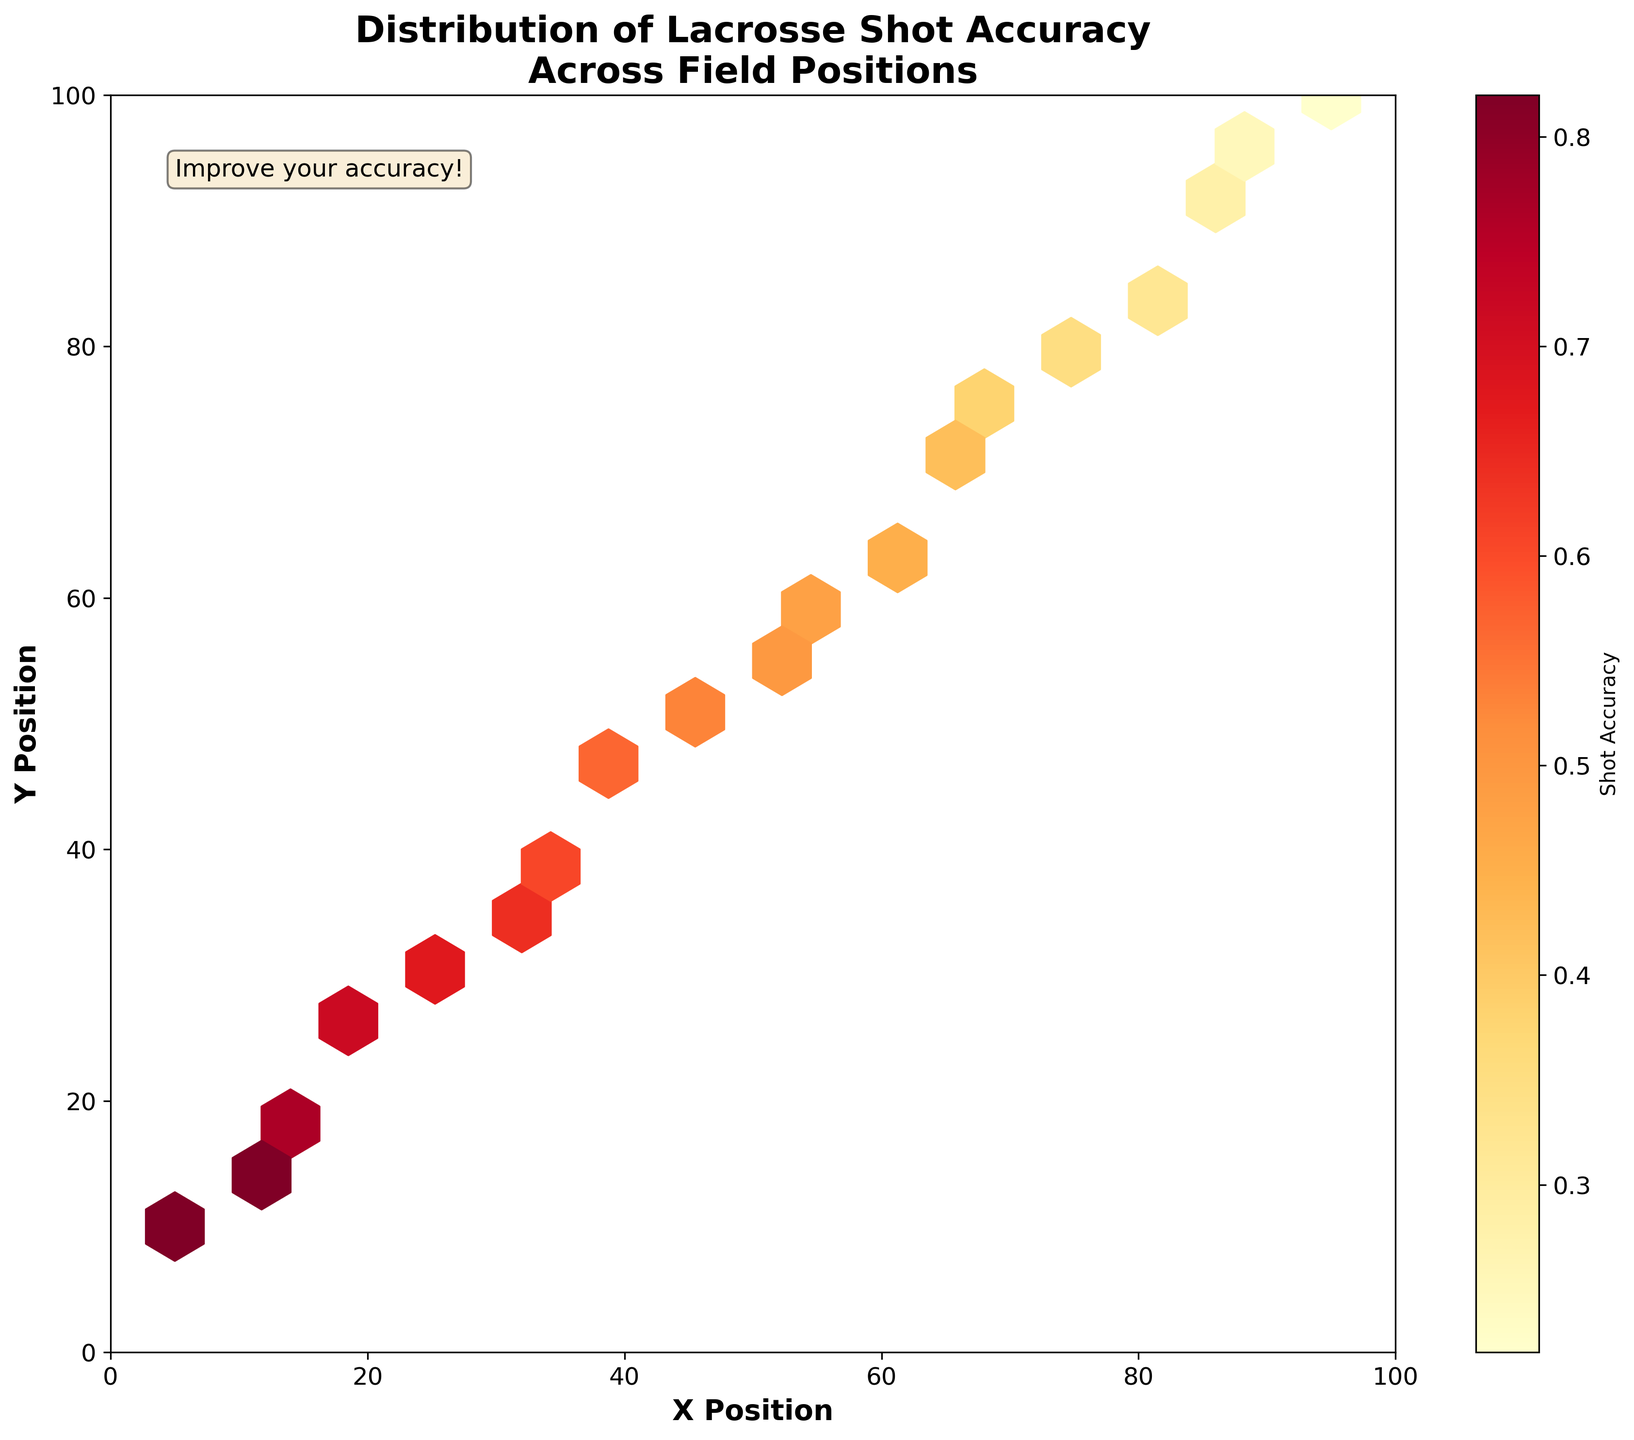What is the title of the figure? The title is located at the top of the plot and is prominently displayed to describe what the plot is about.
Answer: Distribution of Lacrosse Shot Accuracy Across Field Positions What do the axes of the plot represent? The labels on the X and Y axes denote the meaning of the data points along the horizontal and vertical directions respectively.
Answer: The X Position and Y Position on the field What does the color intensity in the hexbin plot represent? The colorbar on the side of the plot shows the gradation from light to dark color, which represents different values of a specific variable.
Answer: Shot Accuracy Which area of the field has the highest shot accuracy? The area with the highest shot accuracy will be represented by the darkest color in the hexbin plot. By locating such a dark region, we determine the highest accuracy area.
Answer: Around the positions (10, 15) and (5, 10) What can you infer about shot accuracy as the Y Position increases? Observing the color changes along the Y-axis from bottom to top helps us understand how shot accuracy varies with position. The transition from dark to lighter colors indicates a trend.
Answer: Shot accuracy generally decreases as Y Position increases Which position has a higher shot accuracy: (40, 45) or (85, 90)? Comparing the color intensity at the two given positions helps determine which has the higher shot accuracy, since the darker color indicates higher accuracy.
Answer: (40, 45) Is there any position in the X range of 45 to 50 that shows high shot accuracy? By observing the region of the plot between X positions 45 and 50 and looking at the color intensity, we check if there are any dark-colored hexagons.
Answer: No, shot accuracy in this range is generally lower How does the shot accuracy at (60, 65) compare to (95, 100)? By examining and comparing the colors at these two positions, we can determine which one has higher or lower shot accuracy.
Answer: (60, 65) has higher shot accuracy than (95, 100) What trend do you notice in shot accuracy as both X and Y positions increase? By observing the color changes across both axes from lower values to higher values, we identify patterns or trends in the shot accuracy. The general transition in colors helps outline the trend.
Answer: Shot accuracy generally decreases as both X and Y positions increase 